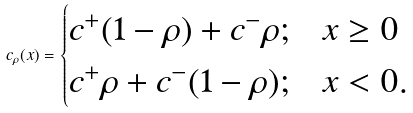<formula> <loc_0><loc_0><loc_500><loc_500>c _ { \rho } ( x ) = \begin{cases} c ^ { + } ( 1 - \rho ) + c ^ { - } \rho ; & x \geq 0 \\ c ^ { + } \rho + c ^ { - } ( 1 - \rho ) ; & x < 0 . \end{cases}</formula> 